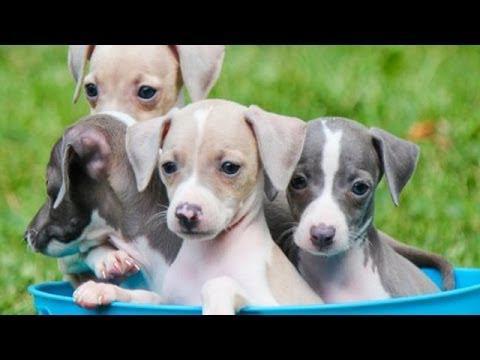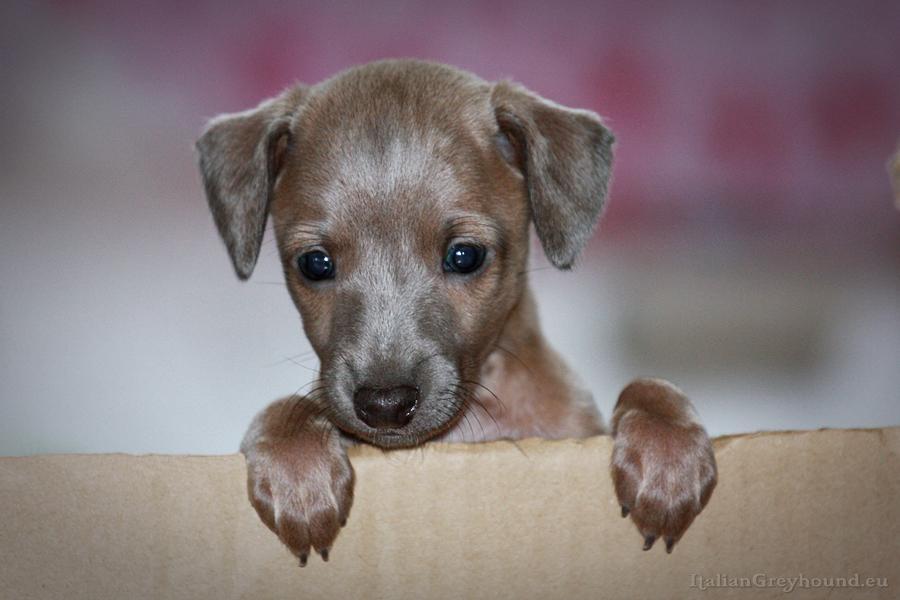The first image is the image on the left, the second image is the image on the right. For the images shown, is this caption "At least one image shows a single dog standing up with only paws touching the ground." true? Answer yes or no. No. 